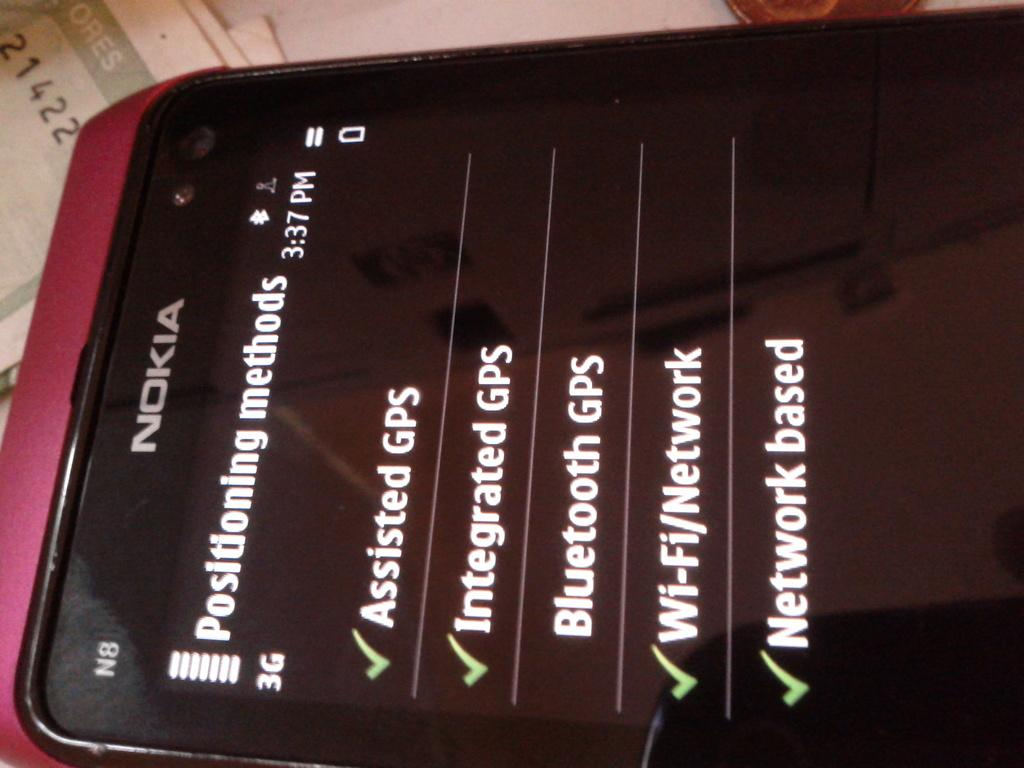<image>
Create a compact narrative representing the image presented. A Nokia cell phone with the Positioning Methods listed below it and some have a green check mark next to them. 